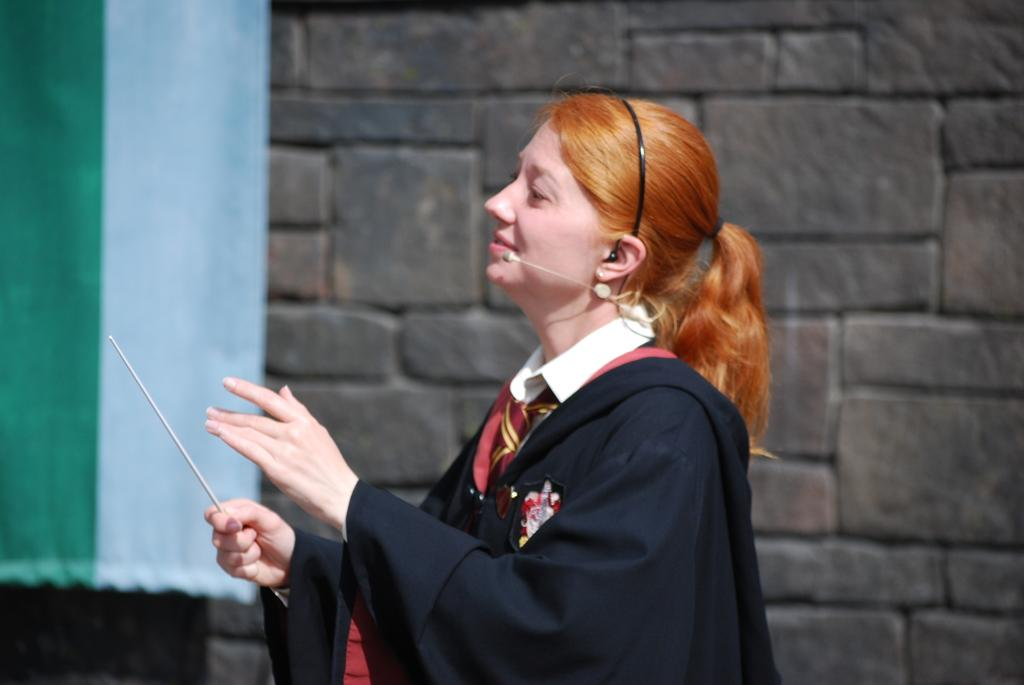What is the main subject of the image? There is a woman standing in the center of the image. What is the woman holding in the image? The woman is holding a stick. What is the woman's facial expression in the image? The woman is smiling. What can be seen in the background of the image? There is a curtain and a wall in the background of the image. How many babies are sitting on the notebook in the image? There is no notebook or babies present in the image. 